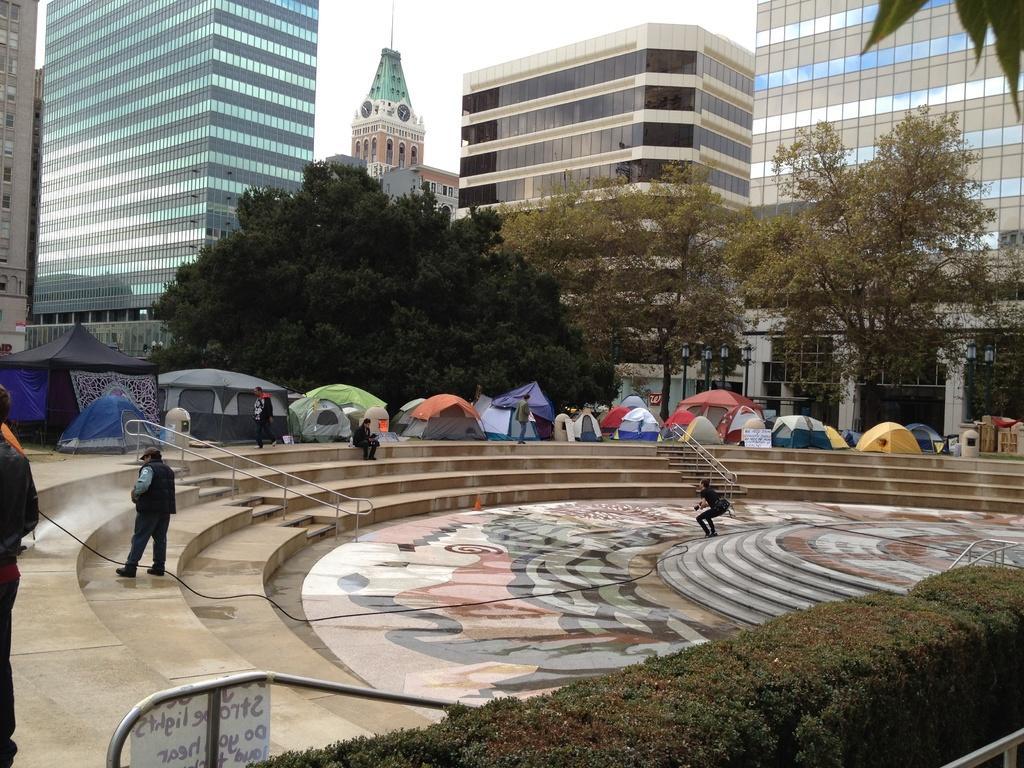Can you describe this image briefly? There are people and we can see plants, board on rods, steps and wire. We can see tents and trees. In the background we can see buildings and sky. 